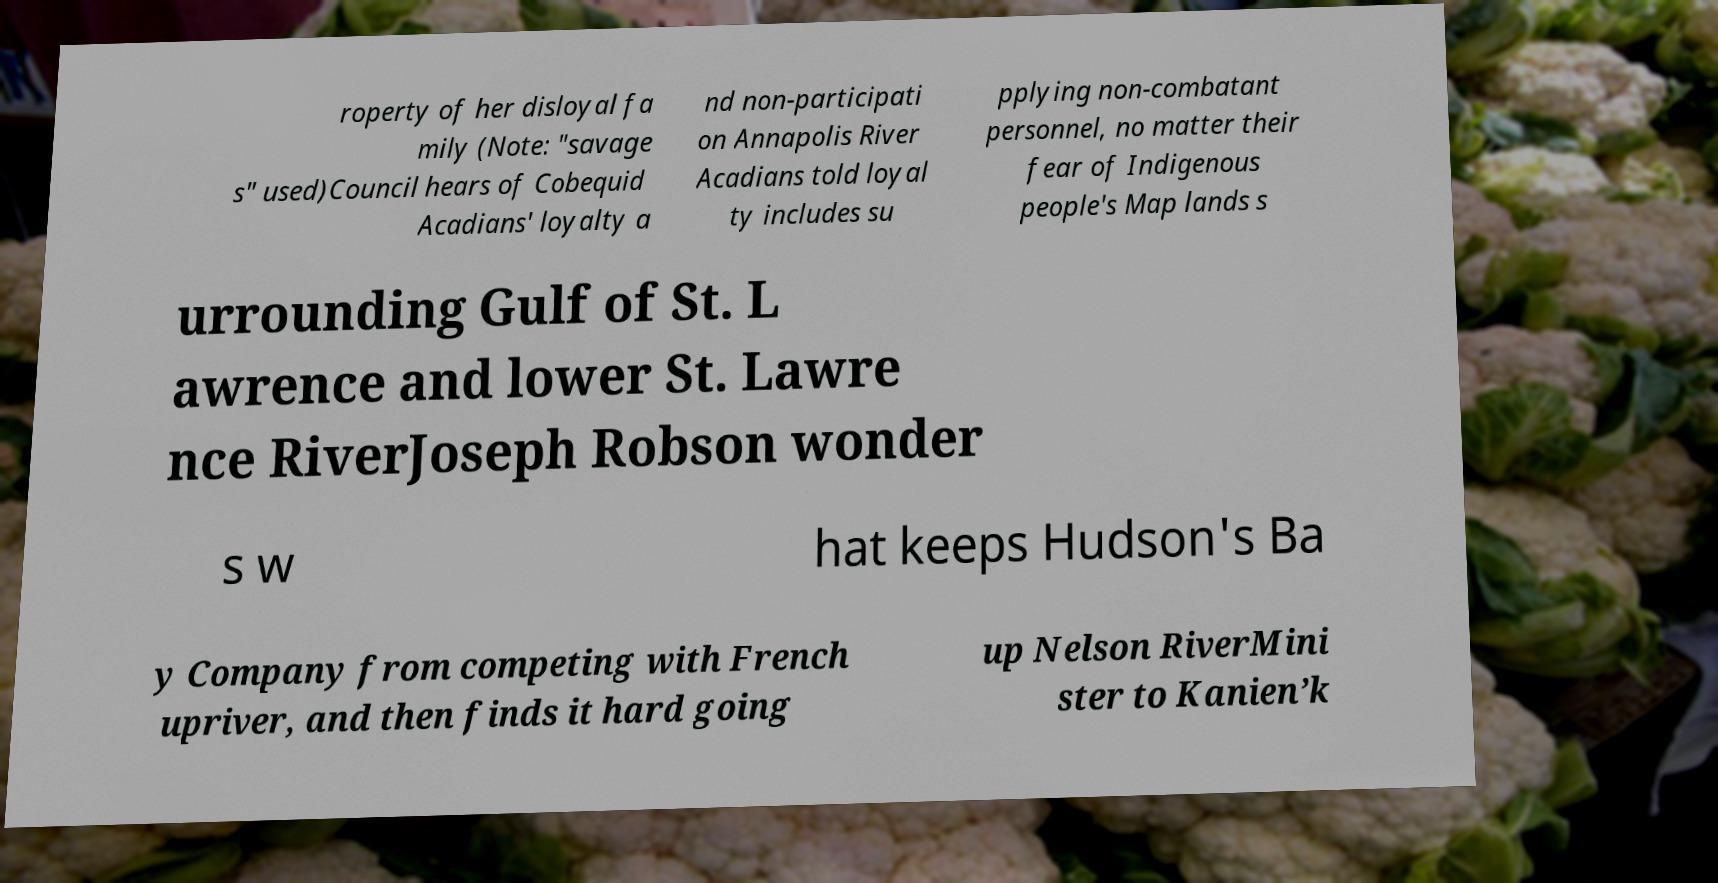I need the written content from this picture converted into text. Can you do that? roperty of her disloyal fa mily (Note: "savage s" used)Council hears of Cobequid Acadians' loyalty a nd non-participati on Annapolis River Acadians told loyal ty includes su pplying non-combatant personnel, no matter their fear of Indigenous people's Map lands s urrounding Gulf of St. L awrence and lower St. Lawre nce RiverJoseph Robson wonder s w hat keeps Hudson's Ba y Company from competing with French upriver, and then finds it hard going up Nelson RiverMini ster to Kanien’k 